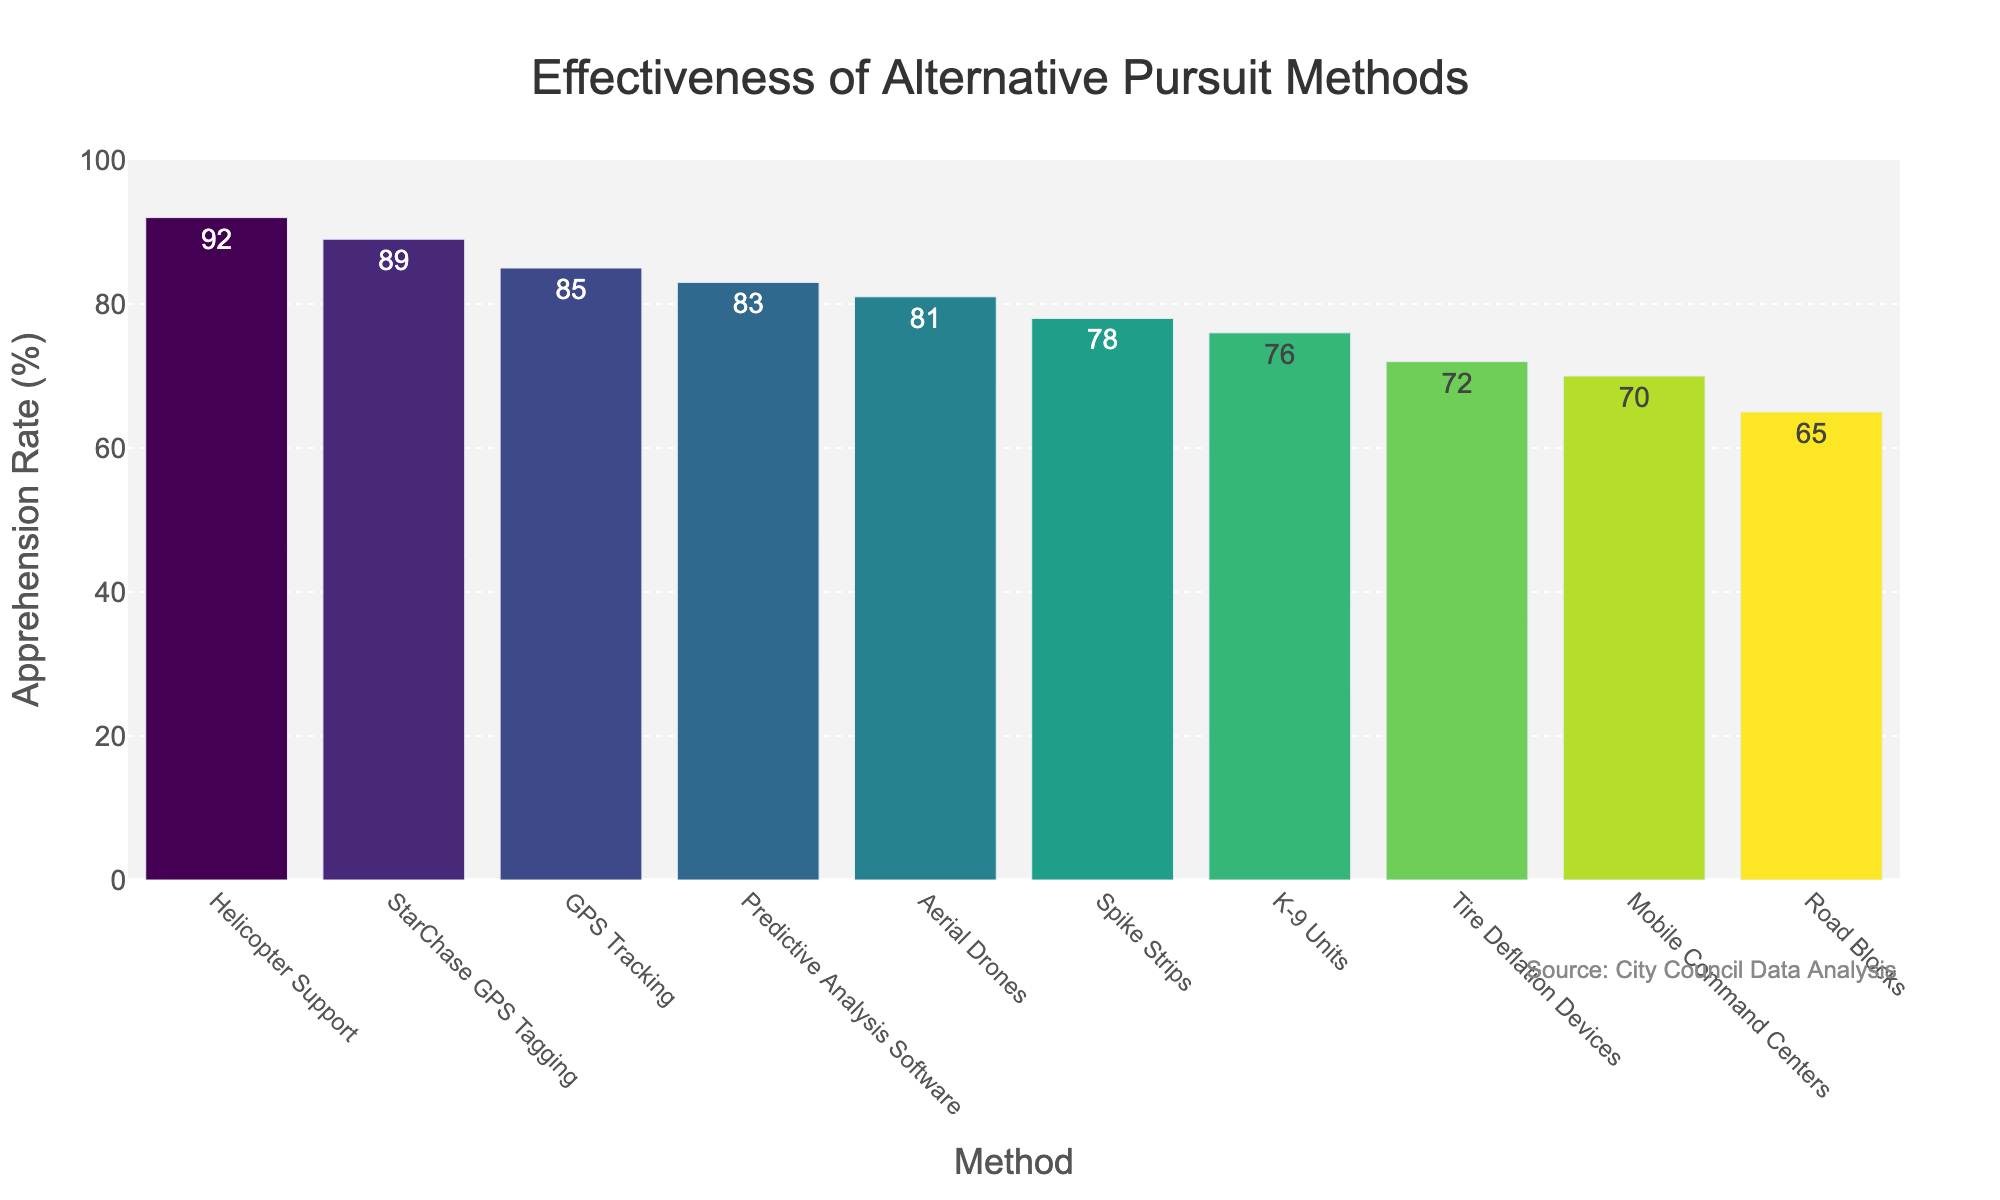Which method has the highest apprehension rate? The method with the highest bar represents the highest apprehension rate. Based on the figure, Helicopter Support has the highest rate.
Answer: Helicopter Support How much higher is the apprehension rate of Helicopter Support compared to Road Blocks? Subtract the apprehension rate of Road Blocks from that of Helicopter Support: 92 - 65 = 27%
Answer: 27% Which methods have an apprehension rate above 80%? Identify the bars that are taller than the 80% mark. The methods are GPS Tracking, Helicopter Support, StarChase GPS Tagging, Aerial Drones, and Predictive Analysis Software.
Answer: GPS Tracking, Helicopter Support, StarChase GPS Tagging, Aerial Drones, Predictive Analysis Software What is the average apprehension rate of all methods? Sum all the apprehension rates and divide by the number of methods: (78 + 85 + 92 + 65 + 89 + 72 + 81 + 70 + 76 + 83) / 10 = 79.1%
Answer: 79.1% Which method has the lowest apprehension rate? The method with the shortest bar represents the lowest apprehension rate. Based on the figure, Road Blocks have the lowest rate.
Answer: Road Blocks How many methods have an apprehension rate between 70% and 80%? Count the bars whose values fall between 70% and 80%. The methods are Spike Strips, Tire Deflation Devices, Mobile Command Centers, and K-9 Units.
Answer: 4 Is the apprehension rate of StarChase GPS Tagging higher or lower than Predictive Analysis Software? Compare the height of the bars representing these methods. StarChase GPS Tagging (89%) is higher than Predictive Analysis Software (83%).
Answer: Higher What is the difference in apprehension rates between Aerial Drones and K-9 Units? Subtract the apprehension rate of K-9 Units from that of Aerial Drones: 81 - 76 = 5%
Answer: 5% Which method has an apprehension rate closest to 80%? Look for the bar that is nearest to the 80% mark. Aerial Drones have an apprehension rate of 81%, which is closest to 80%.
Answer: Aerial Drones 